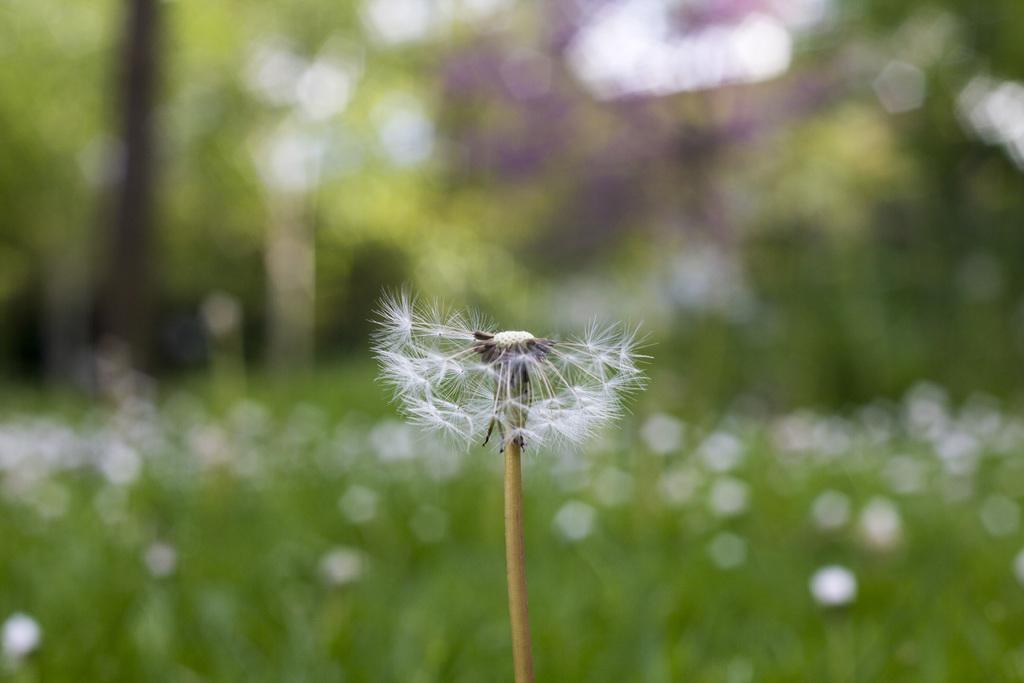Please provide a concise description of this image. In this image I see a dandelion plant which is of white in color. 